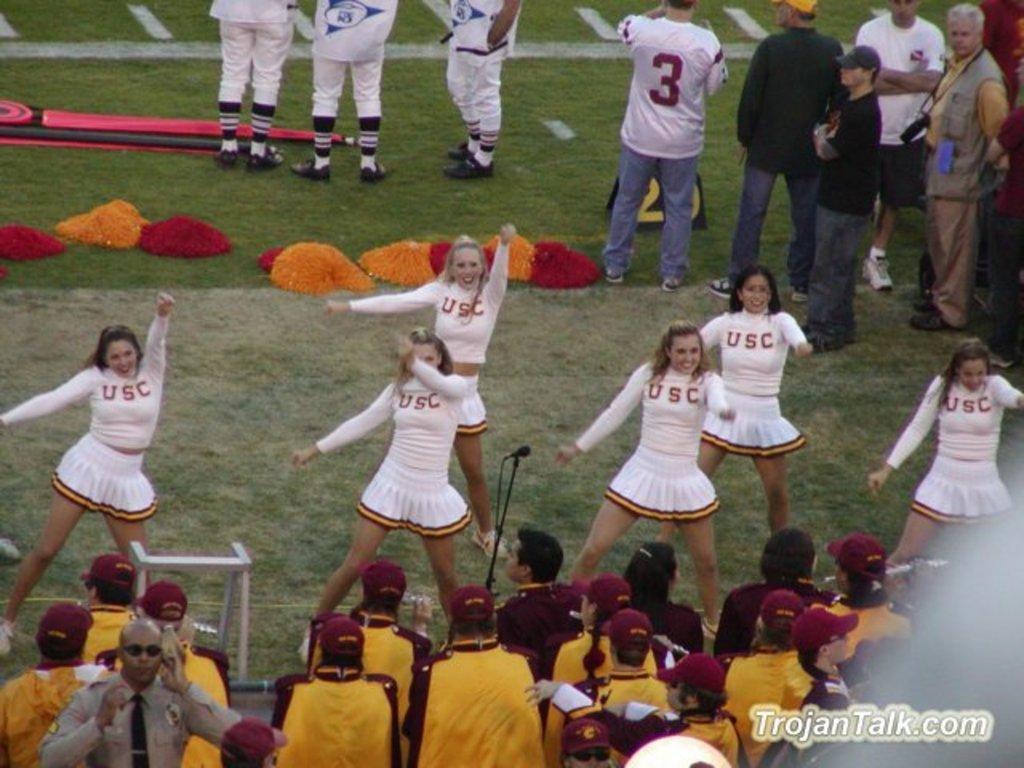What school are these cheerleaders from?
Your response must be concise. Usc. What´s the website on this picture?
Ensure brevity in your answer.  Trojantalk.com. 